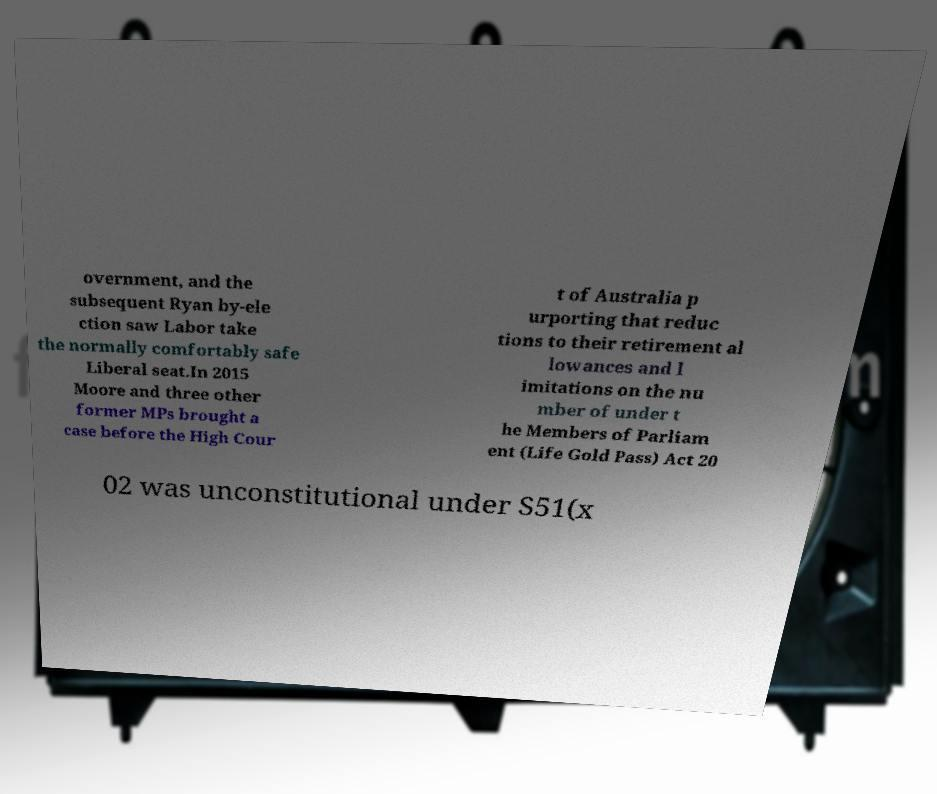I need the written content from this picture converted into text. Can you do that? overnment, and the subsequent Ryan by-ele ction saw Labor take the normally comfortably safe Liberal seat.In 2015 Moore and three other former MPs brought a case before the High Cour t of Australia p urporting that reduc tions to their retirement al lowances and l imitations on the nu mber of under t he Members of Parliam ent (Life Gold Pass) Act 20 02 was unconstitutional under S51(x 